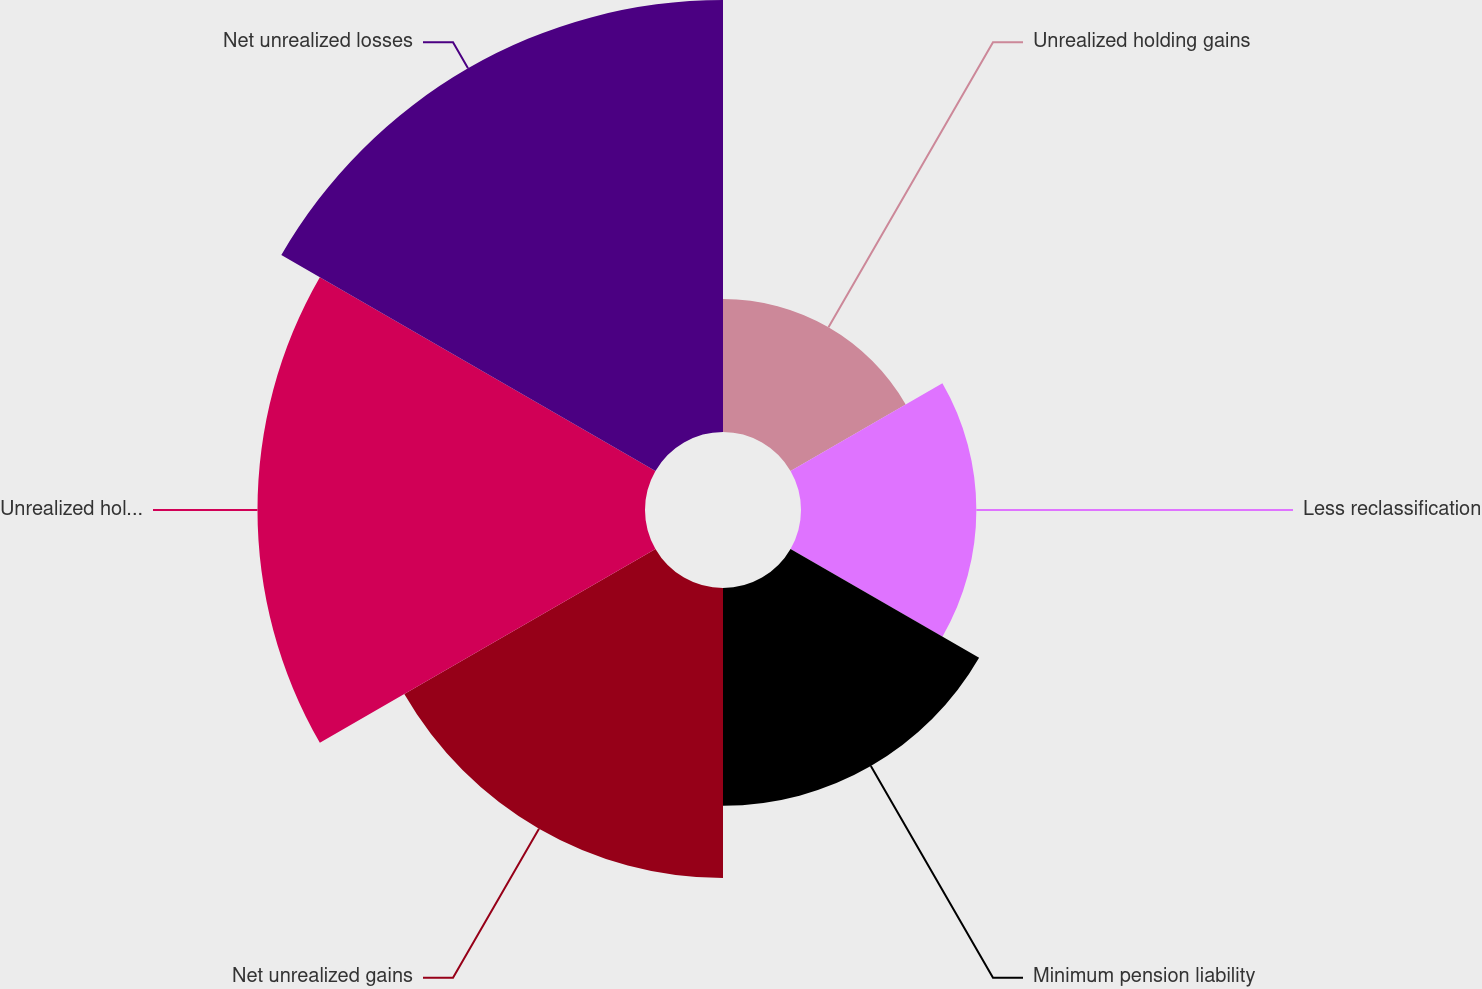Convert chart to OTSL. <chart><loc_0><loc_0><loc_500><loc_500><pie_chart><fcel>Unrealized holding gains<fcel>Less reclassification<fcel>Minimum pension liability<fcel>Net unrealized gains<fcel>Unrealized holding losses<fcel>Net unrealized losses<nl><fcel>8.13%<fcel>10.72%<fcel>13.31%<fcel>17.73%<fcel>23.69%<fcel>26.41%<nl></chart> 